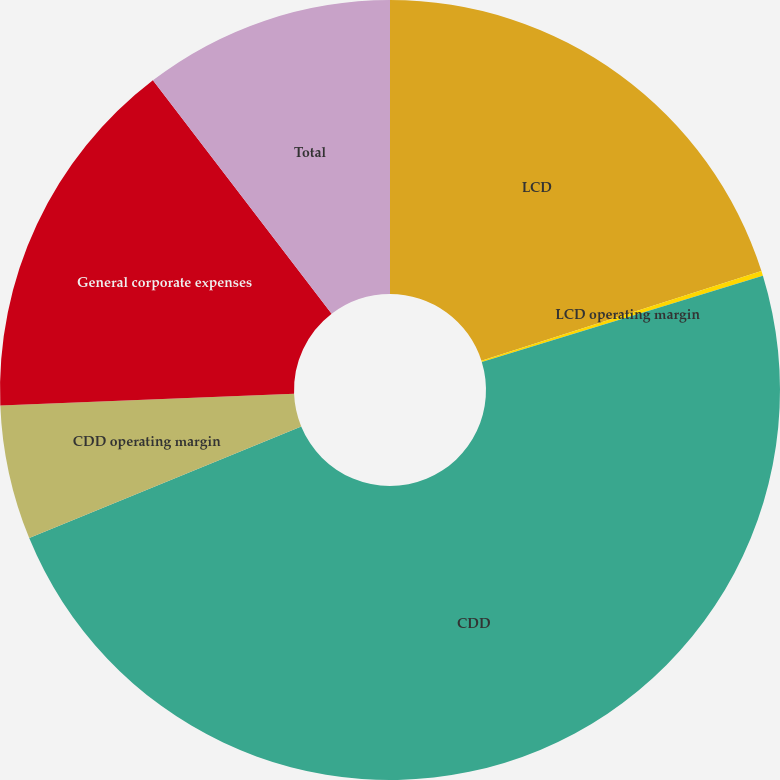<chart> <loc_0><loc_0><loc_500><loc_500><pie_chart><fcel>LCD<fcel>LCD operating margin<fcel>CDD<fcel>CDD operating margin<fcel>General corporate expenses<fcel>Total<nl><fcel>20.07%<fcel>0.2%<fcel>48.53%<fcel>5.57%<fcel>15.23%<fcel>10.4%<nl></chart> 